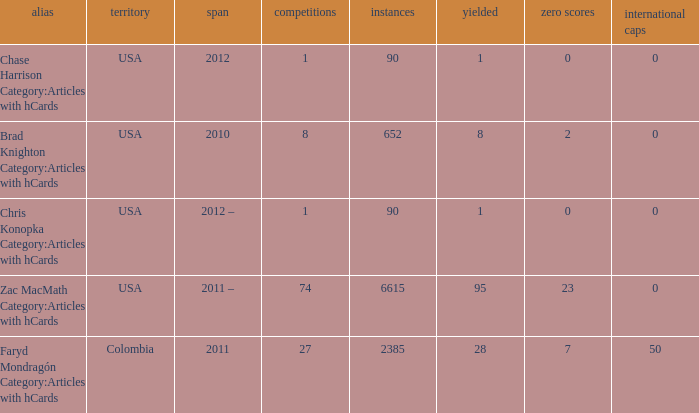When  chris konopka category:articles with hcards is the name what is the year? 2012 –. 